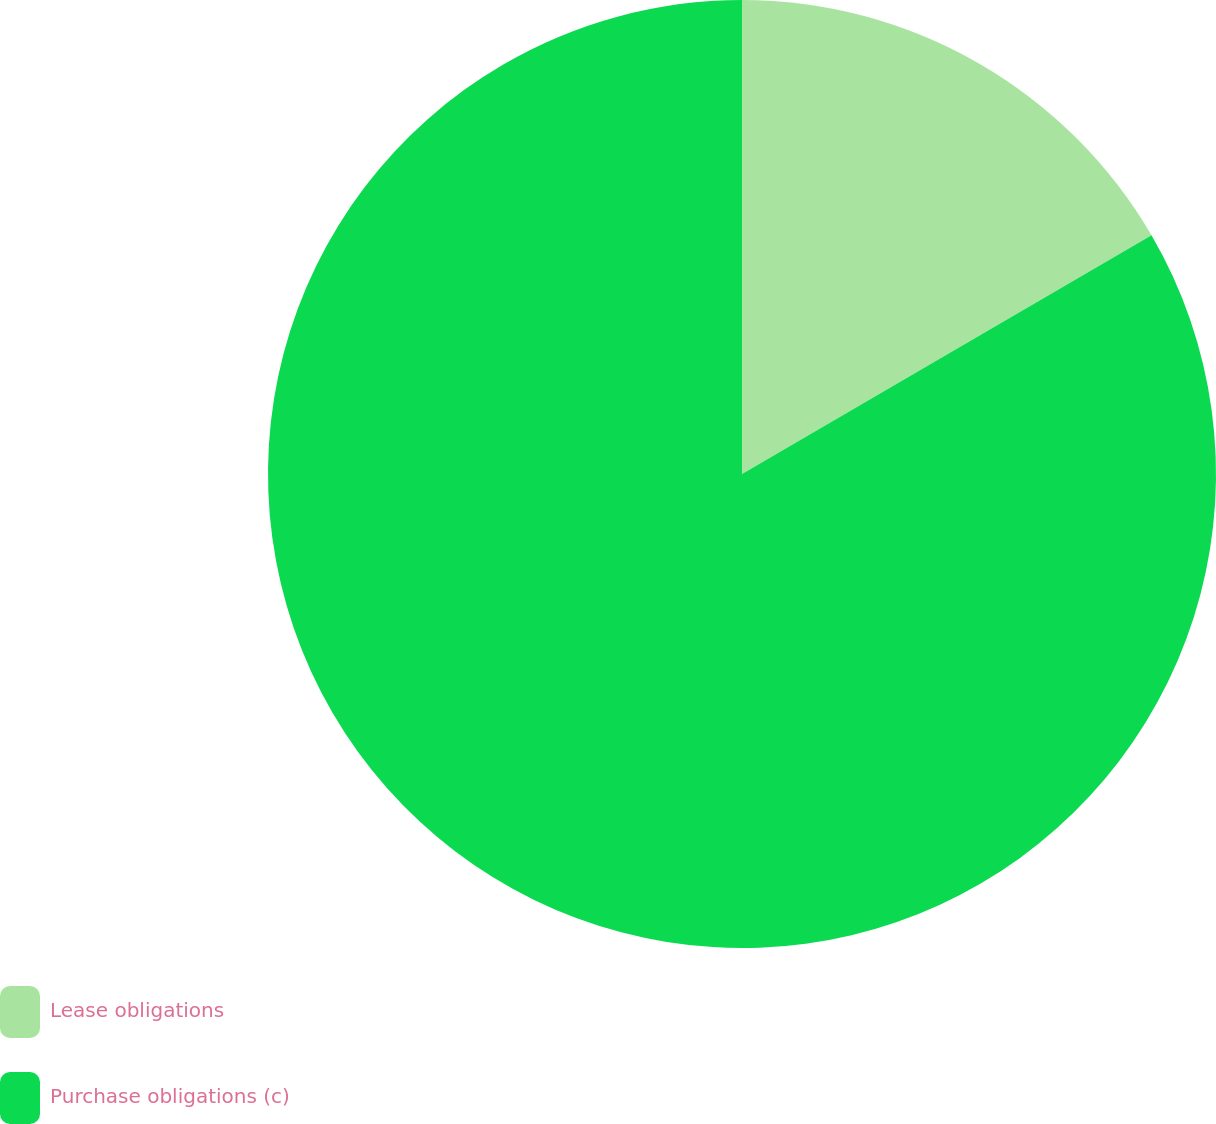<chart> <loc_0><loc_0><loc_500><loc_500><pie_chart><fcel>Lease obligations<fcel>Purchase obligations (c)<nl><fcel>16.6%<fcel>83.4%<nl></chart> 